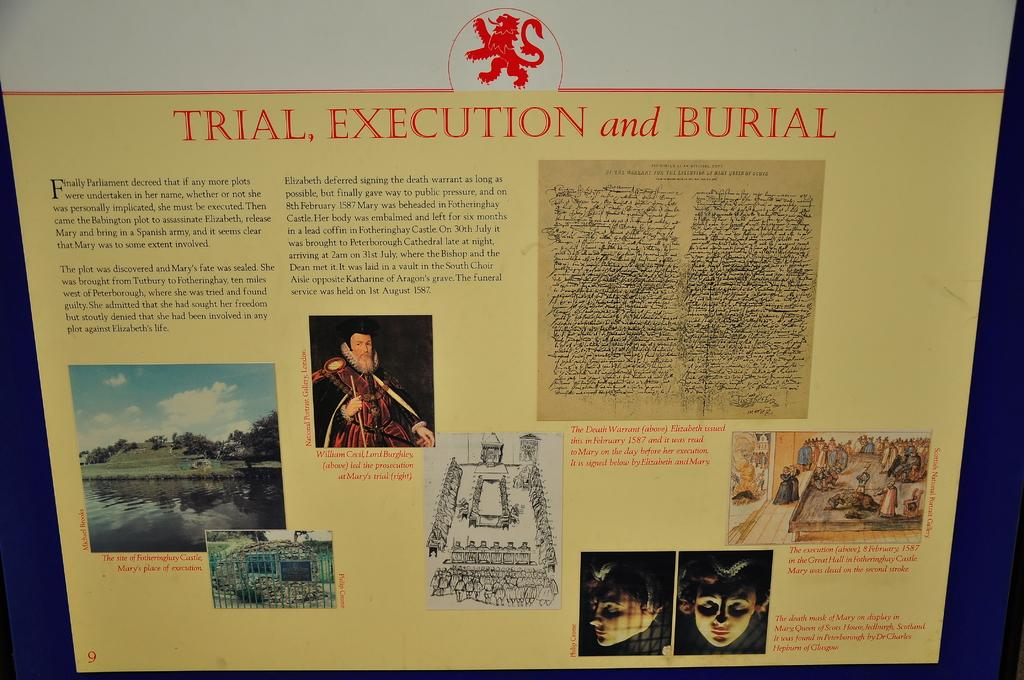Provide a one-sentence caption for the provided image. A POSTER WITH A COLLAGE OF PHOTOS OF THE PARLIMENT. 